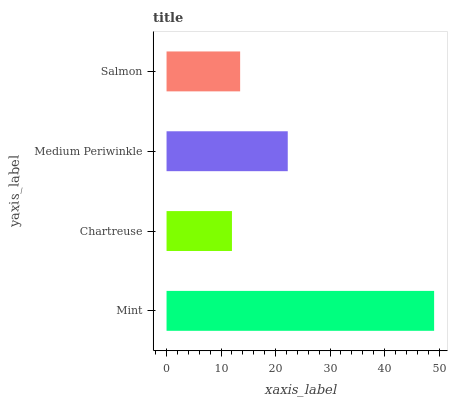Is Chartreuse the minimum?
Answer yes or no. Yes. Is Mint the maximum?
Answer yes or no. Yes. Is Medium Periwinkle the minimum?
Answer yes or no. No. Is Medium Periwinkle the maximum?
Answer yes or no. No. Is Medium Periwinkle greater than Chartreuse?
Answer yes or no. Yes. Is Chartreuse less than Medium Periwinkle?
Answer yes or no. Yes. Is Chartreuse greater than Medium Periwinkle?
Answer yes or no. No. Is Medium Periwinkle less than Chartreuse?
Answer yes or no. No. Is Medium Periwinkle the high median?
Answer yes or no. Yes. Is Salmon the low median?
Answer yes or no. Yes. Is Salmon the high median?
Answer yes or no. No. Is Mint the low median?
Answer yes or no. No. 